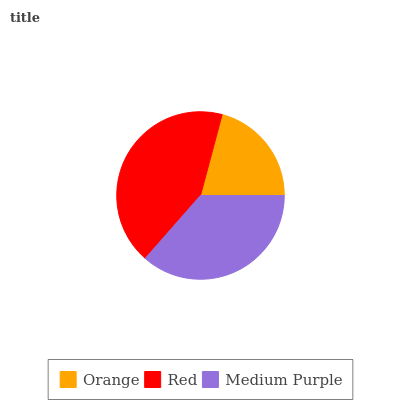Is Orange the minimum?
Answer yes or no. Yes. Is Red the maximum?
Answer yes or no. Yes. Is Medium Purple the minimum?
Answer yes or no. No. Is Medium Purple the maximum?
Answer yes or no. No. Is Red greater than Medium Purple?
Answer yes or no. Yes. Is Medium Purple less than Red?
Answer yes or no. Yes. Is Medium Purple greater than Red?
Answer yes or no. No. Is Red less than Medium Purple?
Answer yes or no. No. Is Medium Purple the high median?
Answer yes or no. Yes. Is Medium Purple the low median?
Answer yes or no. Yes. Is Orange the high median?
Answer yes or no. No. Is Red the low median?
Answer yes or no. No. 